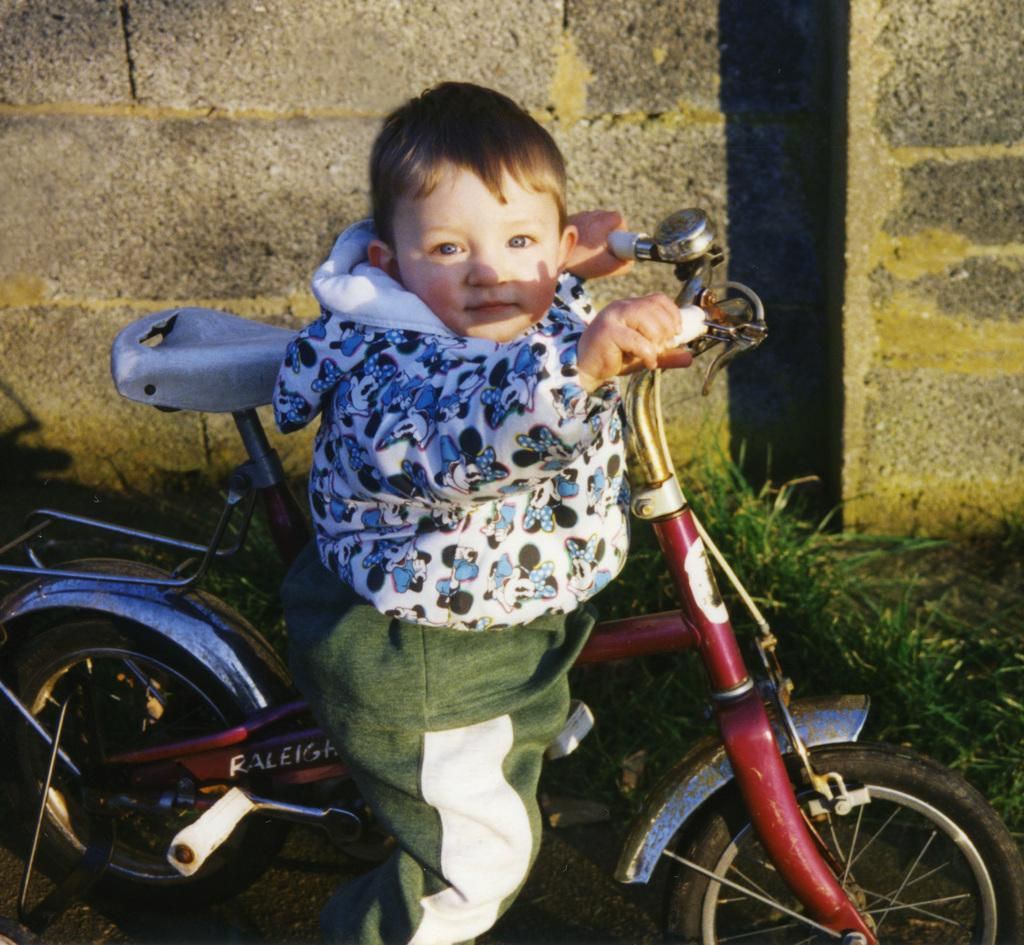What is the main subject of the image? There is a baby in the image. What is the baby doing in the image? The baby is on a cycle. What type of surface is the baby riding the cycle on? The floor is made of grass. What can be seen in the background of the image? There is a brick wall in the background of the image. What type of good-bye message is written on the gate in the image? There is no gate present in the image, and therefore no good-bye message can be observed. 